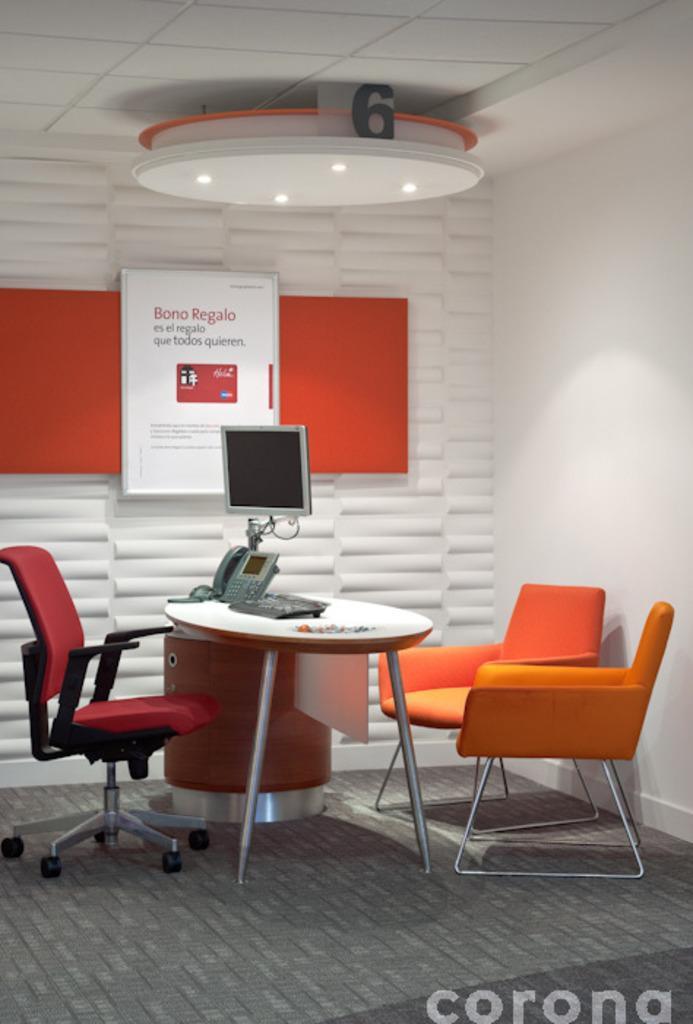Describe this image in one or two sentences. In this picture, we can see chairs and table on the path and on the table there is a keyboard, telephone and monitor. Behind the monitor there is board and there are ceiling lights on the top. On the image there is a watermark. 